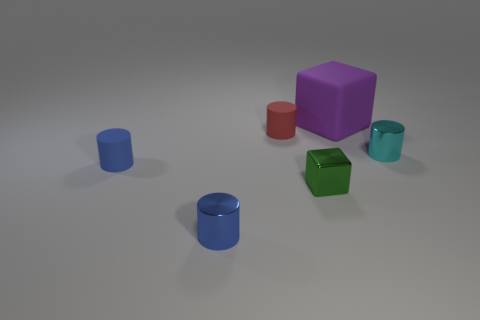Are there fewer big cubes behind the matte block than green metal things that are to the left of the red matte object?
Offer a very short reply. No. Are there any other things that are the same shape as the big purple rubber object?
Keep it short and to the point. Yes. Do the small green thing and the small cyan object have the same shape?
Your response must be concise. No. The metallic block has what size?
Provide a succinct answer. Small. What color is the tiny cylinder that is both in front of the cyan cylinder and behind the small green shiny thing?
Keep it short and to the point. Blue. Is the number of small red matte cylinders greater than the number of cyan matte cylinders?
Your answer should be very brief. Yes. How many things are either metal cubes or small cylinders that are left of the tiny cyan shiny cylinder?
Provide a succinct answer. 4. Is the green cube the same size as the cyan cylinder?
Offer a very short reply. Yes. Are there any green metal cubes left of the red rubber cylinder?
Provide a short and direct response. No. There is a object that is both to the right of the red rubber object and to the left of the large matte thing; what is its size?
Provide a short and direct response. Small. 